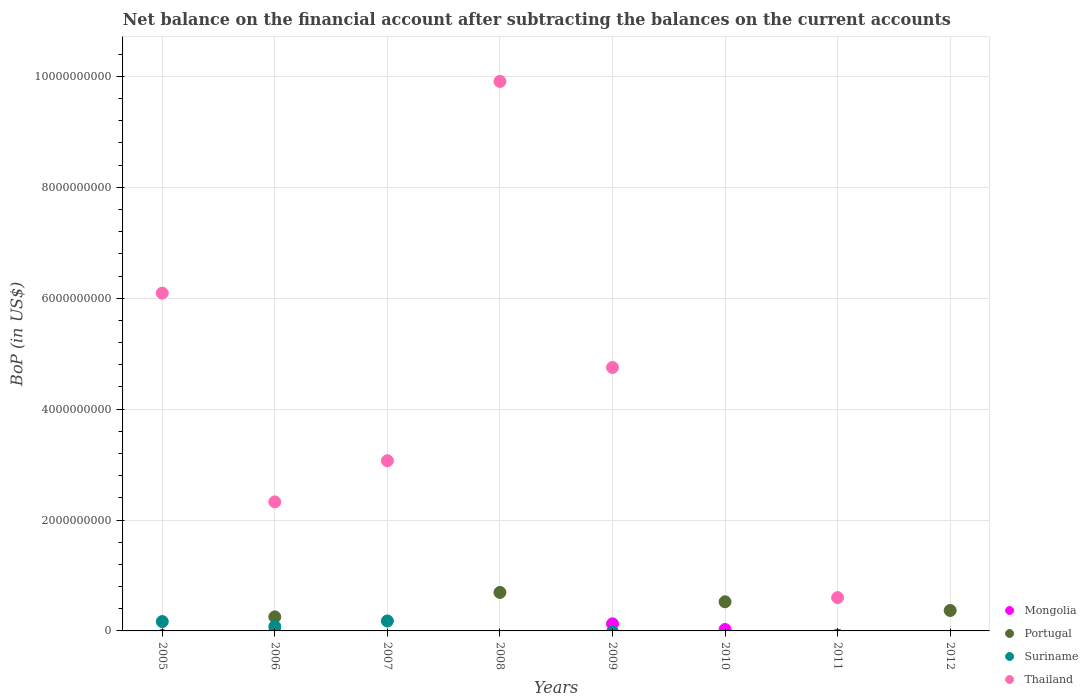Is the number of dotlines equal to the number of legend labels?
Your response must be concise. No. What is the Balance of Payments in Portugal in 2006?
Your response must be concise. 2.53e+08. Across all years, what is the maximum Balance of Payments in Mongolia?
Ensure brevity in your answer.  1.29e+08. Across all years, what is the minimum Balance of Payments in Mongolia?
Your response must be concise. 0. What is the total Balance of Payments in Suriname in the graph?
Provide a succinct answer. 4.28e+08. What is the difference between the Balance of Payments in Suriname in 2005 and that in 2006?
Give a very brief answer. 8.93e+07. What is the difference between the Balance of Payments in Portugal in 2007 and the Balance of Payments in Thailand in 2009?
Provide a succinct answer. -4.75e+09. What is the average Balance of Payments in Mongolia per year?
Keep it short and to the point. 1.93e+07. In the year 2009, what is the difference between the Balance of Payments in Thailand and Balance of Payments in Mongolia?
Provide a short and direct response. 4.62e+09. What is the ratio of the Balance of Payments in Thailand in 2006 to that in 2008?
Your response must be concise. 0.23. Is the Balance of Payments in Suriname in 2005 less than that in 2006?
Give a very brief answer. No. What is the difference between the highest and the second highest Balance of Payments in Thailand?
Your response must be concise. 3.82e+09. What is the difference between the highest and the lowest Balance of Payments in Mongolia?
Your response must be concise. 1.29e+08. In how many years, is the Balance of Payments in Portugal greater than the average Balance of Payments in Portugal taken over all years?
Your response must be concise. 4. Is it the case that in every year, the sum of the Balance of Payments in Mongolia and Balance of Payments in Thailand  is greater than the sum of Balance of Payments in Suriname and Balance of Payments in Portugal?
Ensure brevity in your answer.  No. Is it the case that in every year, the sum of the Balance of Payments in Portugal and Balance of Payments in Mongolia  is greater than the Balance of Payments in Thailand?
Make the answer very short. No. Is the Balance of Payments in Suriname strictly greater than the Balance of Payments in Mongolia over the years?
Provide a succinct answer. No. Is the Balance of Payments in Thailand strictly less than the Balance of Payments in Mongolia over the years?
Give a very brief answer. No. How many years are there in the graph?
Offer a very short reply. 8. What is the difference between two consecutive major ticks on the Y-axis?
Your answer should be very brief. 2.00e+09. Are the values on the major ticks of Y-axis written in scientific E-notation?
Offer a very short reply. No. What is the title of the graph?
Provide a short and direct response. Net balance on the financial account after subtracting the balances on the current accounts. What is the label or title of the X-axis?
Provide a succinct answer. Years. What is the label or title of the Y-axis?
Make the answer very short. BoP (in US$). What is the BoP (in US$) of Portugal in 2005?
Ensure brevity in your answer.  0. What is the BoP (in US$) of Suriname in 2005?
Ensure brevity in your answer.  1.69e+08. What is the BoP (in US$) of Thailand in 2005?
Ensure brevity in your answer.  6.09e+09. What is the BoP (in US$) of Portugal in 2006?
Provide a short and direct response. 2.53e+08. What is the BoP (in US$) in Suriname in 2006?
Provide a short and direct response. 7.95e+07. What is the BoP (in US$) of Thailand in 2006?
Your answer should be compact. 2.33e+09. What is the BoP (in US$) in Mongolia in 2007?
Your response must be concise. 0. What is the BoP (in US$) of Suriname in 2007?
Ensure brevity in your answer.  1.80e+08. What is the BoP (in US$) in Thailand in 2007?
Provide a succinct answer. 3.07e+09. What is the BoP (in US$) in Portugal in 2008?
Your answer should be very brief. 6.94e+08. What is the BoP (in US$) in Thailand in 2008?
Offer a very short reply. 9.91e+09. What is the BoP (in US$) of Mongolia in 2009?
Provide a succinct answer. 1.29e+08. What is the BoP (in US$) of Portugal in 2009?
Give a very brief answer. 0. What is the BoP (in US$) of Suriname in 2009?
Your answer should be very brief. 0. What is the BoP (in US$) of Thailand in 2009?
Your answer should be very brief. 4.75e+09. What is the BoP (in US$) of Mongolia in 2010?
Keep it short and to the point. 2.55e+07. What is the BoP (in US$) of Portugal in 2010?
Offer a very short reply. 5.25e+08. What is the BoP (in US$) of Portugal in 2011?
Your answer should be very brief. 0. What is the BoP (in US$) in Thailand in 2011?
Offer a terse response. 6.01e+08. What is the BoP (in US$) in Portugal in 2012?
Provide a short and direct response. 3.69e+08. What is the BoP (in US$) in Suriname in 2012?
Provide a short and direct response. 0. What is the BoP (in US$) of Thailand in 2012?
Provide a short and direct response. 0. Across all years, what is the maximum BoP (in US$) of Mongolia?
Provide a succinct answer. 1.29e+08. Across all years, what is the maximum BoP (in US$) of Portugal?
Give a very brief answer. 6.94e+08. Across all years, what is the maximum BoP (in US$) of Suriname?
Provide a short and direct response. 1.80e+08. Across all years, what is the maximum BoP (in US$) of Thailand?
Your answer should be compact. 9.91e+09. Across all years, what is the minimum BoP (in US$) in Mongolia?
Provide a succinct answer. 0. Across all years, what is the minimum BoP (in US$) of Portugal?
Offer a terse response. 0. Across all years, what is the minimum BoP (in US$) of Suriname?
Provide a short and direct response. 0. What is the total BoP (in US$) in Mongolia in the graph?
Your response must be concise. 1.54e+08. What is the total BoP (in US$) in Portugal in the graph?
Give a very brief answer. 1.84e+09. What is the total BoP (in US$) of Suriname in the graph?
Your response must be concise. 4.28e+08. What is the total BoP (in US$) of Thailand in the graph?
Ensure brevity in your answer.  2.67e+1. What is the difference between the BoP (in US$) of Suriname in 2005 and that in 2006?
Keep it short and to the point. 8.93e+07. What is the difference between the BoP (in US$) in Thailand in 2005 and that in 2006?
Make the answer very short. 3.76e+09. What is the difference between the BoP (in US$) in Suriname in 2005 and that in 2007?
Offer a terse response. -1.10e+07. What is the difference between the BoP (in US$) in Thailand in 2005 and that in 2007?
Your answer should be very brief. 3.02e+09. What is the difference between the BoP (in US$) of Thailand in 2005 and that in 2008?
Provide a short and direct response. -3.82e+09. What is the difference between the BoP (in US$) in Thailand in 2005 and that in 2009?
Provide a short and direct response. 1.34e+09. What is the difference between the BoP (in US$) of Thailand in 2005 and that in 2011?
Ensure brevity in your answer.  5.49e+09. What is the difference between the BoP (in US$) in Suriname in 2006 and that in 2007?
Make the answer very short. -1.00e+08. What is the difference between the BoP (in US$) of Thailand in 2006 and that in 2007?
Offer a terse response. -7.42e+08. What is the difference between the BoP (in US$) of Portugal in 2006 and that in 2008?
Provide a succinct answer. -4.41e+08. What is the difference between the BoP (in US$) of Thailand in 2006 and that in 2008?
Your answer should be very brief. -7.58e+09. What is the difference between the BoP (in US$) in Thailand in 2006 and that in 2009?
Give a very brief answer. -2.42e+09. What is the difference between the BoP (in US$) in Portugal in 2006 and that in 2010?
Provide a short and direct response. -2.72e+08. What is the difference between the BoP (in US$) of Thailand in 2006 and that in 2011?
Give a very brief answer. 1.73e+09. What is the difference between the BoP (in US$) of Portugal in 2006 and that in 2012?
Provide a short and direct response. -1.15e+08. What is the difference between the BoP (in US$) of Thailand in 2007 and that in 2008?
Give a very brief answer. -6.84e+09. What is the difference between the BoP (in US$) of Thailand in 2007 and that in 2009?
Offer a terse response. -1.68e+09. What is the difference between the BoP (in US$) of Thailand in 2007 and that in 2011?
Offer a very short reply. 2.47e+09. What is the difference between the BoP (in US$) in Thailand in 2008 and that in 2009?
Your response must be concise. 5.16e+09. What is the difference between the BoP (in US$) in Portugal in 2008 and that in 2010?
Keep it short and to the point. 1.69e+08. What is the difference between the BoP (in US$) in Thailand in 2008 and that in 2011?
Your response must be concise. 9.31e+09. What is the difference between the BoP (in US$) of Portugal in 2008 and that in 2012?
Provide a succinct answer. 3.26e+08. What is the difference between the BoP (in US$) in Mongolia in 2009 and that in 2010?
Keep it short and to the point. 1.03e+08. What is the difference between the BoP (in US$) in Thailand in 2009 and that in 2011?
Ensure brevity in your answer.  4.15e+09. What is the difference between the BoP (in US$) in Portugal in 2010 and that in 2012?
Keep it short and to the point. 1.57e+08. What is the difference between the BoP (in US$) of Suriname in 2005 and the BoP (in US$) of Thailand in 2006?
Offer a terse response. -2.16e+09. What is the difference between the BoP (in US$) of Suriname in 2005 and the BoP (in US$) of Thailand in 2007?
Offer a terse response. -2.90e+09. What is the difference between the BoP (in US$) of Suriname in 2005 and the BoP (in US$) of Thailand in 2008?
Keep it short and to the point. -9.74e+09. What is the difference between the BoP (in US$) of Suriname in 2005 and the BoP (in US$) of Thailand in 2009?
Offer a terse response. -4.58e+09. What is the difference between the BoP (in US$) in Suriname in 2005 and the BoP (in US$) in Thailand in 2011?
Your answer should be very brief. -4.32e+08. What is the difference between the BoP (in US$) in Portugal in 2006 and the BoP (in US$) in Suriname in 2007?
Your answer should be very brief. 7.36e+07. What is the difference between the BoP (in US$) of Portugal in 2006 and the BoP (in US$) of Thailand in 2007?
Provide a short and direct response. -2.82e+09. What is the difference between the BoP (in US$) of Suriname in 2006 and the BoP (in US$) of Thailand in 2007?
Provide a short and direct response. -2.99e+09. What is the difference between the BoP (in US$) in Portugal in 2006 and the BoP (in US$) in Thailand in 2008?
Make the answer very short. -9.66e+09. What is the difference between the BoP (in US$) in Suriname in 2006 and the BoP (in US$) in Thailand in 2008?
Your answer should be very brief. -9.83e+09. What is the difference between the BoP (in US$) in Portugal in 2006 and the BoP (in US$) in Thailand in 2009?
Offer a very short reply. -4.50e+09. What is the difference between the BoP (in US$) in Suriname in 2006 and the BoP (in US$) in Thailand in 2009?
Keep it short and to the point. -4.67e+09. What is the difference between the BoP (in US$) in Portugal in 2006 and the BoP (in US$) in Thailand in 2011?
Provide a short and direct response. -3.47e+08. What is the difference between the BoP (in US$) of Suriname in 2006 and the BoP (in US$) of Thailand in 2011?
Provide a succinct answer. -5.21e+08. What is the difference between the BoP (in US$) in Suriname in 2007 and the BoP (in US$) in Thailand in 2008?
Your answer should be compact. -9.73e+09. What is the difference between the BoP (in US$) in Suriname in 2007 and the BoP (in US$) in Thailand in 2009?
Your answer should be very brief. -4.57e+09. What is the difference between the BoP (in US$) in Suriname in 2007 and the BoP (in US$) in Thailand in 2011?
Provide a short and direct response. -4.21e+08. What is the difference between the BoP (in US$) of Portugal in 2008 and the BoP (in US$) of Thailand in 2009?
Give a very brief answer. -4.06e+09. What is the difference between the BoP (in US$) in Portugal in 2008 and the BoP (in US$) in Thailand in 2011?
Keep it short and to the point. 9.37e+07. What is the difference between the BoP (in US$) of Mongolia in 2009 and the BoP (in US$) of Portugal in 2010?
Give a very brief answer. -3.97e+08. What is the difference between the BoP (in US$) of Mongolia in 2009 and the BoP (in US$) of Thailand in 2011?
Your response must be concise. -4.72e+08. What is the difference between the BoP (in US$) in Mongolia in 2009 and the BoP (in US$) in Portugal in 2012?
Your response must be concise. -2.40e+08. What is the difference between the BoP (in US$) of Mongolia in 2010 and the BoP (in US$) of Thailand in 2011?
Keep it short and to the point. -5.75e+08. What is the difference between the BoP (in US$) in Portugal in 2010 and the BoP (in US$) in Thailand in 2011?
Ensure brevity in your answer.  -7.53e+07. What is the difference between the BoP (in US$) in Mongolia in 2010 and the BoP (in US$) in Portugal in 2012?
Ensure brevity in your answer.  -3.43e+08. What is the average BoP (in US$) of Mongolia per year?
Offer a very short reply. 1.93e+07. What is the average BoP (in US$) of Portugal per year?
Your answer should be very brief. 2.30e+08. What is the average BoP (in US$) of Suriname per year?
Offer a very short reply. 5.35e+07. What is the average BoP (in US$) in Thailand per year?
Give a very brief answer. 3.34e+09. In the year 2005, what is the difference between the BoP (in US$) of Suriname and BoP (in US$) of Thailand?
Keep it short and to the point. -5.92e+09. In the year 2006, what is the difference between the BoP (in US$) in Portugal and BoP (in US$) in Suriname?
Offer a very short reply. 1.74e+08. In the year 2006, what is the difference between the BoP (in US$) of Portugal and BoP (in US$) of Thailand?
Ensure brevity in your answer.  -2.07e+09. In the year 2006, what is the difference between the BoP (in US$) of Suriname and BoP (in US$) of Thailand?
Your answer should be compact. -2.25e+09. In the year 2007, what is the difference between the BoP (in US$) in Suriname and BoP (in US$) in Thailand?
Provide a short and direct response. -2.89e+09. In the year 2008, what is the difference between the BoP (in US$) of Portugal and BoP (in US$) of Thailand?
Ensure brevity in your answer.  -9.21e+09. In the year 2009, what is the difference between the BoP (in US$) in Mongolia and BoP (in US$) in Thailand?
Keep it short and to the point. -4.62e+09. In the year 2010, what is the difference between the BoP (in US$) of Mongolia and BoP (in US$) of Portugal?
Your answer should be very brief. -5.00e+08. What is the ratio of the BoP (in US$) of Suriname in 2005 to that in 2006?
Your response must be concise. 2.12. What is the ratio of the BoP (in US$) in Thailand in 2005 to that in 2006?
Make the answer very short. 2.62. What is the ratio of the BoP (in US$) in Suriname in 2005 to that in 2007?
Offer a very short reply. 0.94. What is the ratio of the BoP (in US$) in Thailand in 2005 to that in 2007?
Provide a short and direct response. 1.98. What is the ratio of the BoP (in US$) of Thailand in 2005 to that in 2008?
Give a very brief answer. 0.61. What is the ratio of the BoP (in US$) in Thailand in 2005 to that in 2009?
Your response must be concise. 1.28. What is the ratio of the BoP (in US$) in Thailand in 2005 to that in 2011?
Your answer should be very brief. 10.14. What is the ratio of the BoP (in US$) of Suriname in 2006 to that in 2007?
Offer a terse response. 0.44. What is the ratio of the BoP (in US$) of Thailand in 2006 to that in 2007?
Make the answer very short. 0.76. What is the ratio of the BoP (in US$) in Portugal in 2006 to that in 2008?
Make the answer very short. 0.36. What is the ratio of the BoP (in US$) in Thailand in 2006 to that in 2008?
Offer a very short reply. 0.23. What is the ratio of the BoP (in US$) of Thailand in 2006 to that in 2009?
Make the answer very short. 0.49. What is the ratio of the BoP (in US$) of Portugal in 2006 to that in 2010?
Offer a very short reply. 0.48. What is the ratio of the BoP (in US$) of Thailand in 2006 to that in 2011?
Your answer should be very brief. 3.87. What is the ratio of the BoP (in US$) of Portugal in 2006 to that in 2012?
Ensure brevity in your answer.  0.69. What is the ratio of the BoP (in US$) of Thailand in 2007 to that in 2008?
Your response must be concise. 0.31. What is the ratio of the BoP (in US$) of Thailand in 2007 to that in 2009?
Offer a very short reply. 0.65. What is the ratio of the BoP (in US$) of Thailand in 2007 to that in 2011?
Ensure brevity in your answer.  5.11. What is the ratio of the BoP (in US$) in Thailand in 2008 to that in 2009?
Offer a terse response. 2.09. What is the ratio of the BoP (in US$) in Portugal in 2008 to that in 2010?
Make the answer very short. 1.32. What is the ratio of the BoP (in US$) of Thailand in 2008 to that in 2011?
Keep it short and to the point. 16.5. What is the ratio of the BoP (in US$) in Portugal in 2008 to that in 2012?
Provide a short and direct response. 1.88. What is the ratio of the BoP (in US$) of Mongolia in 2009 to that in 2010?
Make the answer very short. 5.03. What is the ratio of the BoP (in US$) of Thailand in 2009 to that in 2011?
Provide a succinct answer. 7.91. What is the ratio of the BoP (in US$) of Portugal in 2010 to that in 2012?
Provide a succinct answer. 1.43. What is the difference between the highest and the second highest BoP (in US$) of Portugal?
Your answer should be very brief. 1.69e+08. What is the difference between the highest and the second highest BoP (in US$) in Suriname?
Your answer should be compact. 1.10e+07. What is the difference between the highest and the second highest BoP (in US$) of Thailand?
Give a very brief answer. 3.82e+09. What is the difference between the highest and the lowest BoP (in US$) of Mongolia?
Your answer should be compact. 1.29e+08. What is the difference between the highest and the lowest BoP (in US$) in Portugal?
Offer a terse response. 6.94e+08. What is the difference between the highest and the lowest BoP (in US$) in Suriname?
Give a very brief answer. 1.80e+08. What is the difference between the highest and the lowest BoP (in US$) of Thailand?
Keep it short and to the point. 9.91e+09. 